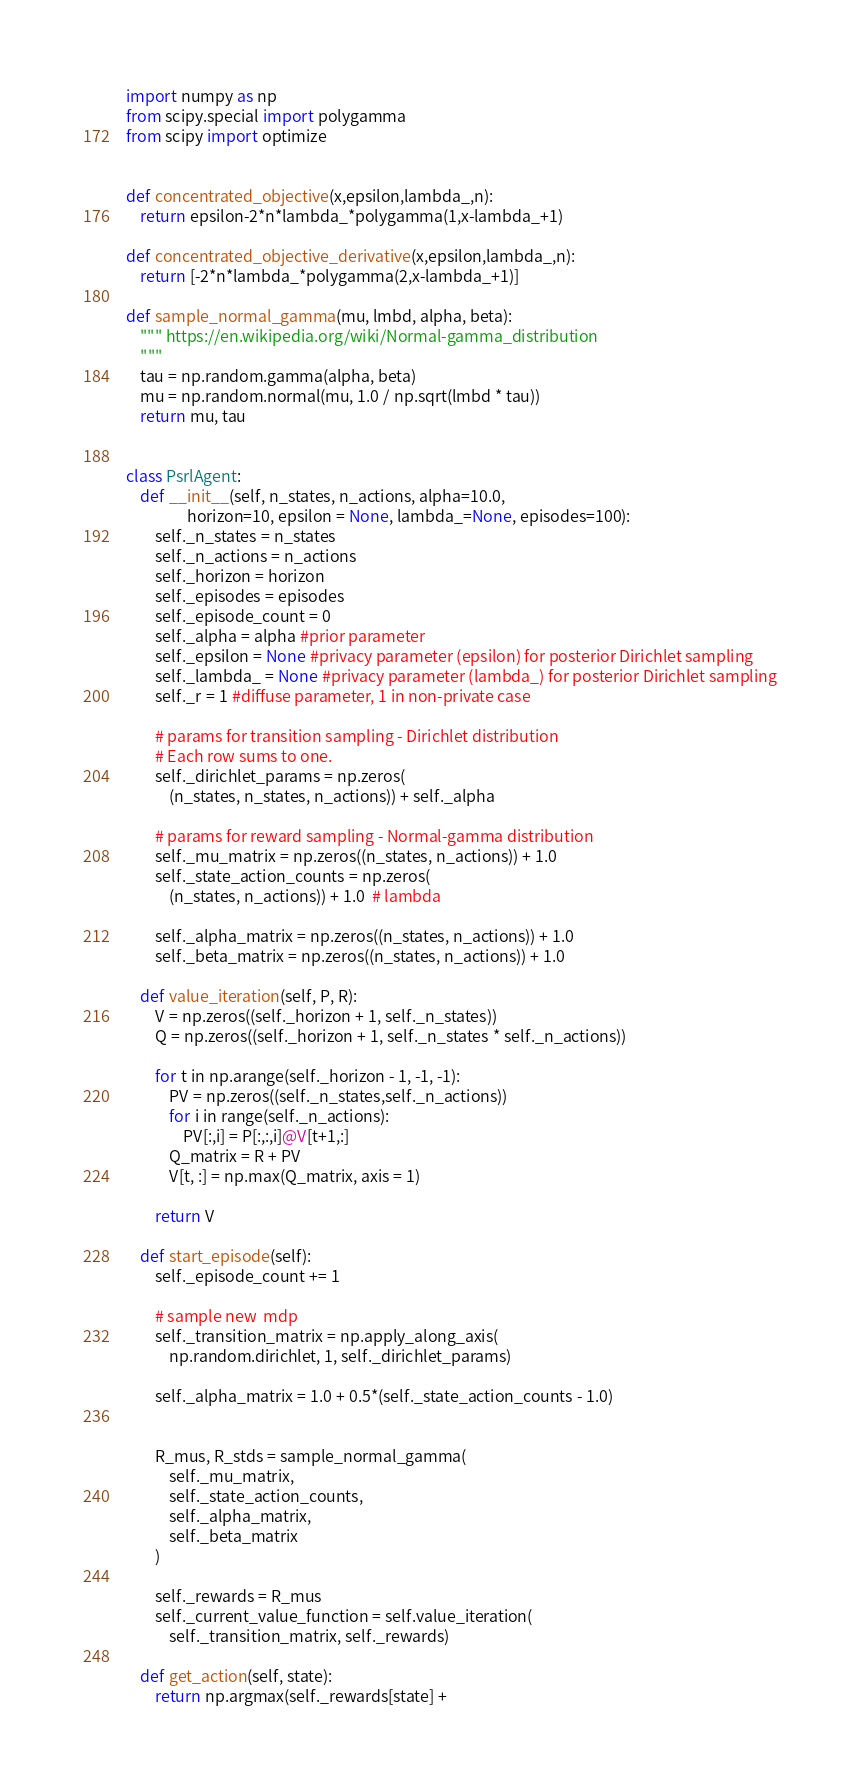<code> <loc_0><loc_0><loc_500><loc_500><_Python_>import numpy as np
from scipy.special import polygamma
from scipy import optimize


def concentrated_objective(x,epsilon,lambda_,n):
    return epsilon-2*n*lambda_*polygamma(1,x-lambda_+1)

def concentrated_objective_derivative(x,epsilon,lambda_,n):
    return [-2*n*lambda_*polygamma(2,x-lambda_+1)]

def sample_normal_gamma(mu, lmbd, alpha, beta):
    """ https://en.wikipedia.org/wiki/Normal-gamma_distribution
    """
    tau = np.random.gamma(alpha, beta)
    mu = np.random.normal(mu, 1.0 / np.sqrt(lmbd * tau))
    return mu, tau


class PsrlAgent:
    def __init__(self, n_states, n_actions, alpha=10.0, 
                 horizon=10, epsilon = None, lambda_=None, episodes=100):
        self._n_states = n_states
        self._n_actions = n_actions
        self._horizon = horizon
        self._episodes = episodes
        self._episode_count = 0
        self._alpha = alpha #prior parameter
        self._epsilon = None #privacy parameter (epsilon) for posterior Dirichlet sampling
        self._lambda_ = None #privacy parameter (lambda_) for posterior Dirichlet sampling
        self._r = 1 #diffuse parameter, 1 in non-private case

        # params for transition sampling - Dirichlet distribution
        # Each row sums to one.
        self._dirichlet_params = np.zeros(
            (n_states, n_states, n_actions)) + self._alpha

        # params for reward sampling - Normal-gamma distribution
        self._mu_matrix = np.zeros((n_states, n_actions)) + 1.0
        self._state_action_counts = np.zeros(
            (n_states, n_actions)) + 1.0  # lambda

        self._alpha_matrix = np.zeros((n_states, n_actions)) + 1.0
        self._beta_matrix = np.zeros((n_states, n_actions)) + 1.0

    def value_iteration(self, P, R):
        V = np.zeros((self._horizon + 1, self._n_states))
        Q = np.zeros((self._horizon + 1, self._n_states * self._n_actions))        

        for t in np.arange(self._horizon - 1, -1, -1):
            PV = np.zeros((self._n_states,self._n_actions))
            for i in range(self._n_actions):
                PV[:,i] = P[:,:,i]@V[t+1,:]
            Q_matrix = R + PV
            V[t, :] = np.max(Q_matrix, axis = 1)

        return V

    def start_episode(self):
        self._episode_count += 1
        
        # sample new  mdp
        self._transition_matrix = np.apply_along_axis(
            np.random.dirichlet, 1, self._dirichlet_params)
        
        self._alpha_matrix = 1.0 + 0.5*(self._state_action_counts - 1.0)
        
        
        R_mus, R_stds = sample_normal_gamma(
            self._mu_matrix,
            self._state_action_counts,
            self._alpha_matrix,
            self._beta_matrix
        )

        self._rewards = R_mus
        self._current_value_function = self.value_iteration(
            self._transition_matrix, self._rewards)
        
    def get_action(self, state):
        return np.argmax(self._rewards[state] +</code> 